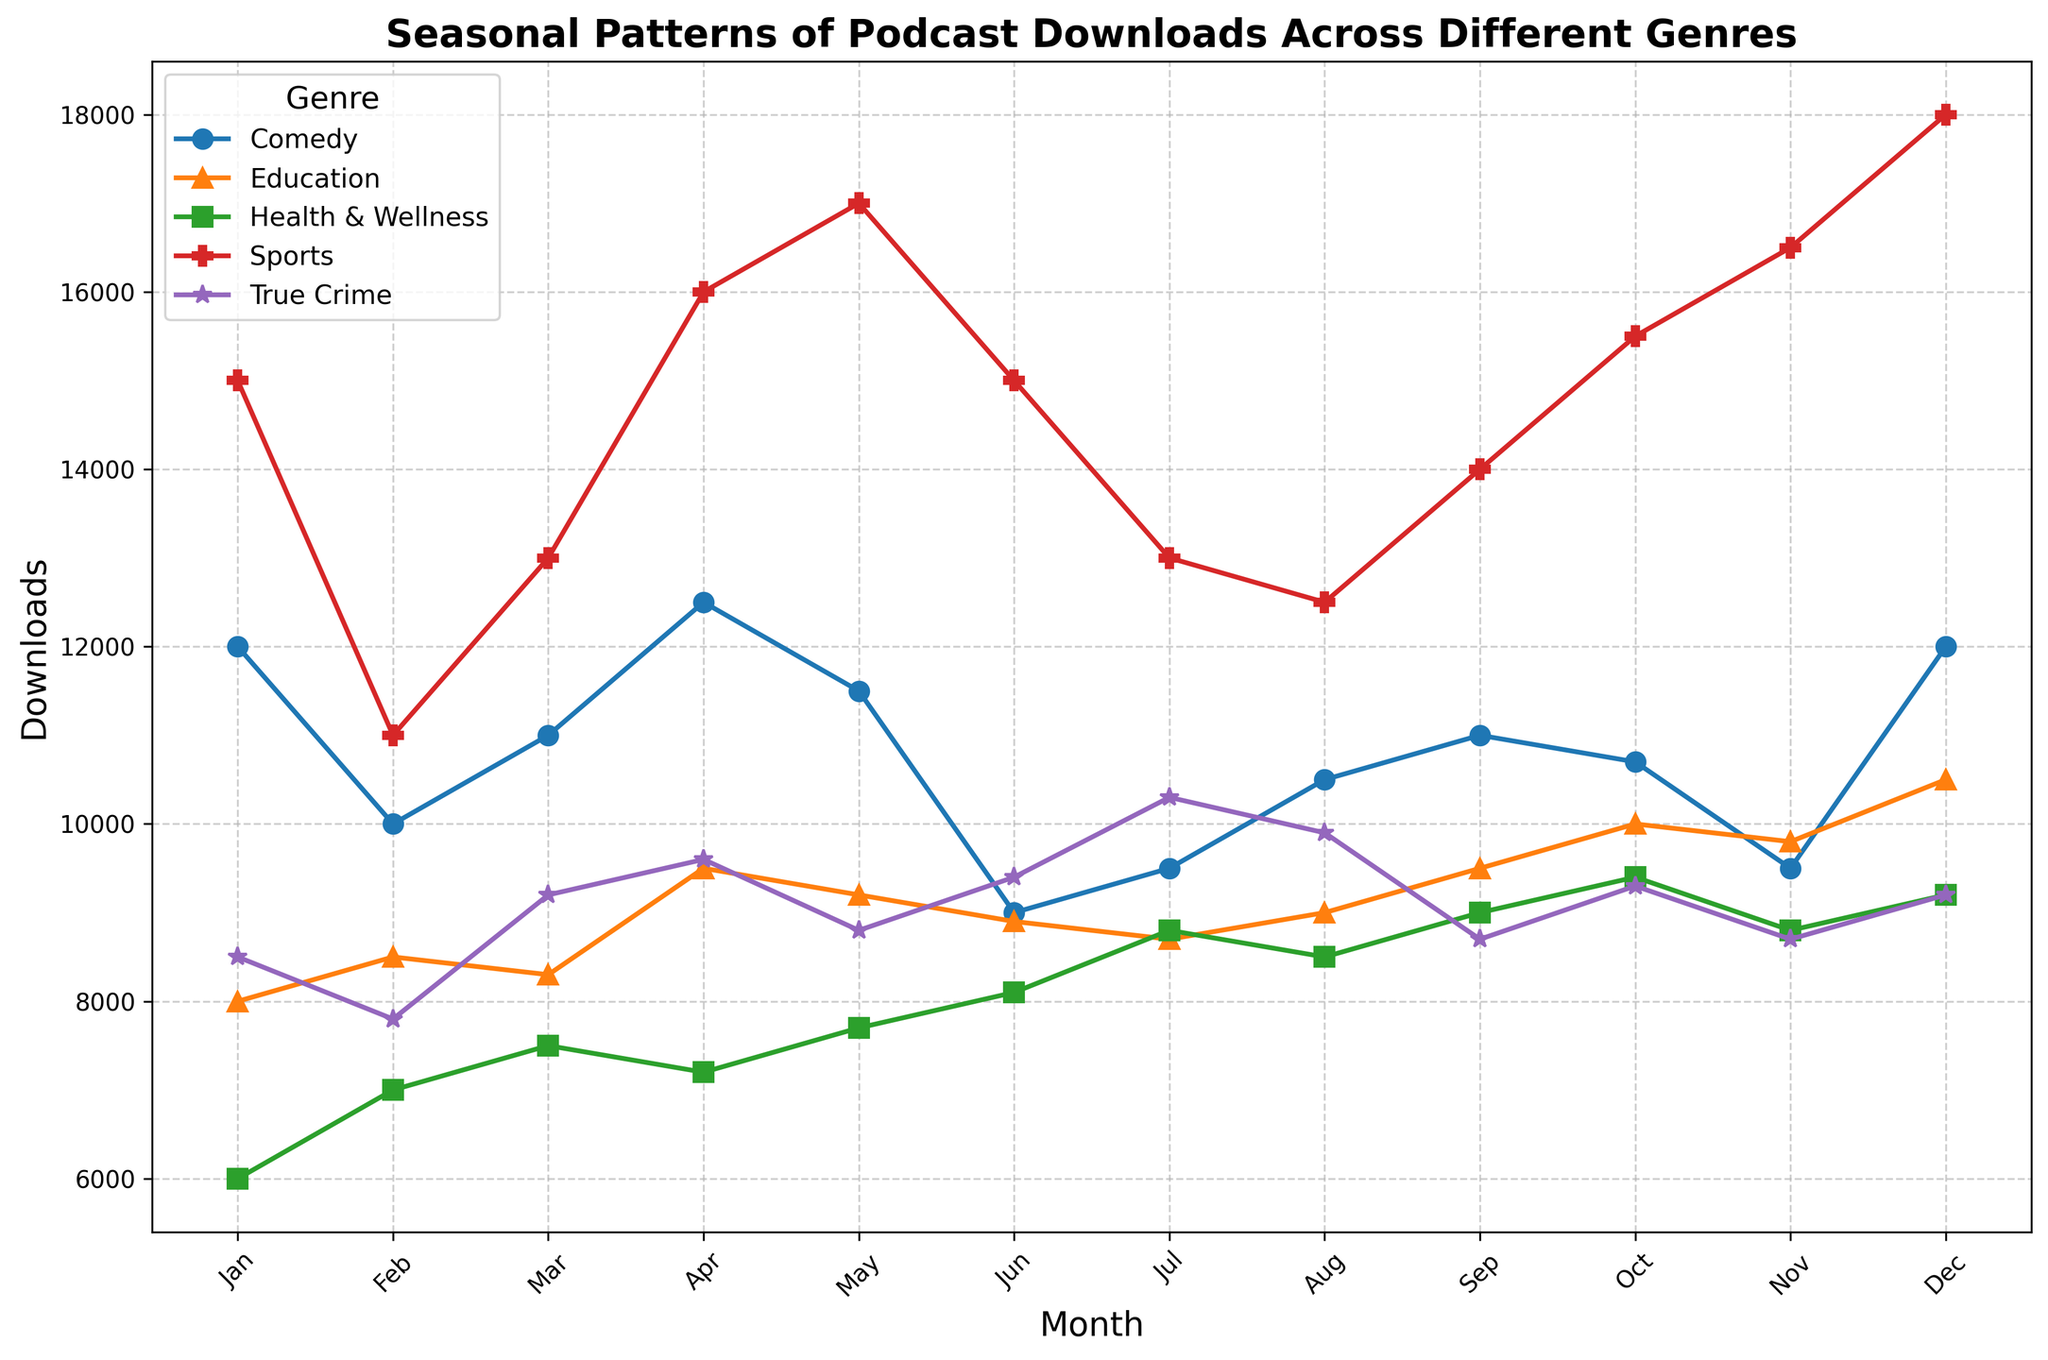What genre has the highest downloads in December? In December, look at the endpoints of each line and identify which line is the highest on the y-axis. The 'Sports' line is the highest, indicating it has the most downloads.
Answer: Sports Which months have the lowest downloads for the Comedy genre? Trace the Comedy line (usually orange) and identify the points on the chart. The lowest points are in February and June.
Answer: February and June What's the difference in downloads between Health & Wellness in January and October? Locate the values on the y-axis for Health & Wellness in January (6000) and October (9400). Subtract January's downloads from October's. 9400 - 6000 = 3400.
Answer: 3400 In which month does Sports experience the largest increase in downloads from the previous month? Track the Sports line and note changes between consecutive months. The biggest jump is from November (16500) to December (18000), a difference of 1500 downloads.
Answer: December What is the average number of downloads for True Crime in the first quarter of the year? (Jan, Feb, Mar) Add the downloads from January (8500), February (7800), and March (9200). Then divide by 3 to get the average. (8500 + 7800 + 9200) / 3 = 18300 / 3 = 8600.
Answer: 8600 Does the Education genre ever have more downloads than the Comedy genre in any month? Compare each month's data points for Education (typically a purplish line) and Comedy (usually orange). In no month does Education exceed Comedy.
Answer: No Which genre shows the most consistent downloads throughout the year (least variation)? Visually inspect the genres for stable, flat lines without sharp peaks or drops. Education shows the least fluctuation in the number of downloads.
Answer: Education Between which months does the Comedy genre experience its steepest decline in downloads? Follow the Comedy line and observe the steepest downward slope. The largest decrease is from April (12500) to June (9000).
Answer: April to June What's the peak download month for True Crime? Locate the highest point on the True Crime line. It peaks in July at 10300 downloads.
Answer: July Compare the downloads for Health & Wellness and True Crime in August. Which genre has more downloads? Find the y-values for Health & Wellness (8500) and True Crime (9900) in August. True Crime has more downloads.
Answer: True Crime 